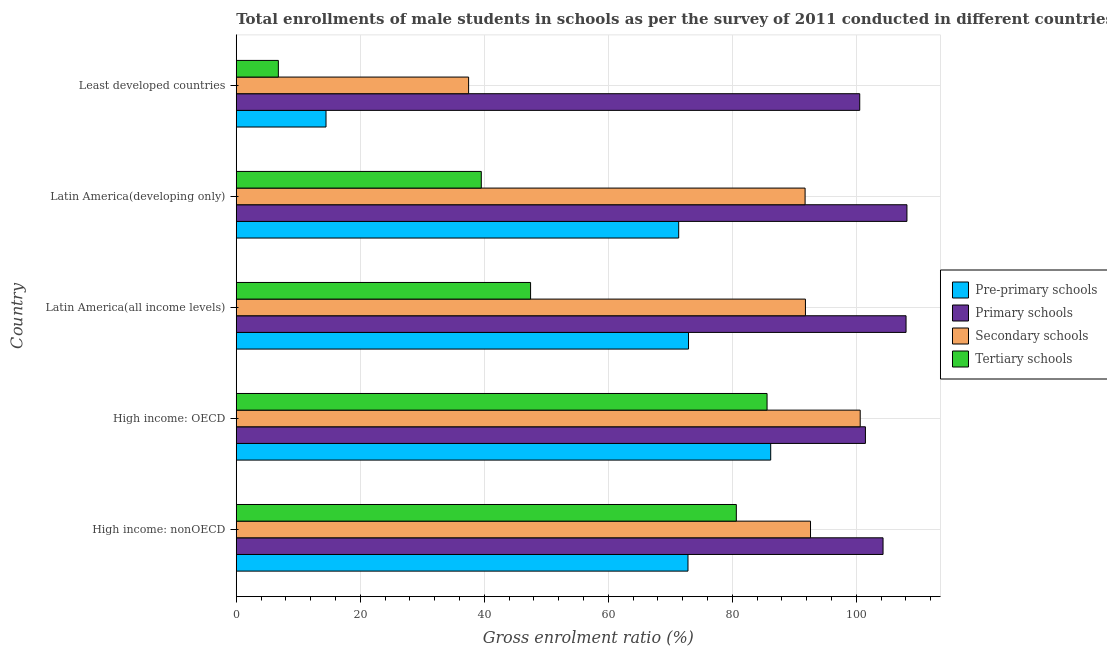What is the label of the 2nd group of bars from the top?
Make the answer very short. Latin America(developing only). What is the gross enrolment ratio(male) in secondary schools in High income: OECD?
Your answer should be compact. 100.64. Across all countries, what is the maximum gross enrolment ratio(male) in secondary schools?
Your answer should be very brief. 100.64. Across all countries, what is the minimum gross enrolment ratio(male) in pre-primary schools?
Your answer should be compact. 14.48. In which country was the gross enrolment ratio(male) in secondary schools maximum?
Make the answer very short. High income: OECD. In which country was the gross enrolment ratio(male) in pre-primary schools minimum?
Provide a succinct answer. Least developed countries. What is the total gross enrolment ratio(male) in primary schools in the graph?
Keep it short and to the point. 522.57. What is the difference between the gross enrolment ratio(male) in secondary schools in High income: OECD and that in Latin America(all income levels)?
Make the answer very short. 8.83. What is the difference between the gross enrolment ratio(male) in secondary schools in High income: OECD and the gross enrolment ratio(male) in primary schools in High income: nonOECD?
Make the answer very short. -3.68. What is the average gross enrolment ratio(male) in secondary schools per country?
Offer a very short reply. 82.86. What is the difference between the gross enrolment ratio(male) in secondary schools and gross enrolment ratio(male) in pre-primary schools in Least developed countries?
Provide a short and direct response. 23. What is the ratio of the gross enrolment ratio(male) in pre-primary schools in High income: nonOECD to that in Least developed countries?
Keep it short and to the point. 5.03. Is the gross enrolment ratio(male) in tertiary schools in High income: nonOECD less than that in Least developed countries?
Your answer should be compact. No. What is the difference between the highest and the second highest gross enrolment ratio(male) in primary schools?
Your answer should be compact. 0.15. What is the difference between the highest and the lowest gross enrolment ratio(male) in secondary schools?
Offer a very short reply. 63.16. Is the sum of the gross enrolment ratio(male) in primary schools in Latin America(developing only) and Least developed countries greater than the maximum gross enrolment ratio(male) in pre-primary schools across all countries?
Your answer should be very brief. Yes. What does the 4th bar from the top in Latin America(developing only) represents?
Provide a short and direct response. Pre-primary schools. What does the 4th bar from the bottom in High income: OECD represents?
Your answer should be compact. Tertiary schools. How many bars are there?
Provide a short and direct response. 20. Does the graph contain any zero values?
Offer a terse response. No. What is the title of the graph?
Keep it short and to the point. Total enrollments of male students in schools as per the survey of 2011 conducted in different countries. What is the label or title of the X-axis?
Provide a short and direct response. Gross enrolment ratio (%). What is the Gross enrolment ratio (%) in Pre-primary schools in High income: nonOECD?
Make the answer very short. 72.86. What is the Gross enrolment ratio (%) in Primary schools in High income: nonOECD?
Give a very brief answer. 104.32. What is the Gross enrolment ratio (%) in Secondary schools in High income: nonOECD?
Ensure brevity in your answer.  92.62. What is the Gross enrolment ratio (%) in Tertiary schools in High income: nonOECD?
Keep it short and to the point. 80.66. What is the Gross enrolment ratio (%) of Pre-primary schools in High income: OECD?
Provide a short and direct response. 86.2. What is the Gross enrolment ratio (%) in Primary schools in High income: OECD?
Your answer should be very brief. 101.48. What is the Gross enrolment ratio (%) in Secondary schools in High income: OECD?
Offer a very short reply. 100.64. What is the Gross enrolment ratio (%) of Tertiary schools in High income: OECD?
Offer a very short reply. 85.61. What is the Gross enrolment ratio (%) in Pre-primary schools in Latin America(all income levels)?
Offer a very short reply. 72.95. What is the Gross enrolment ratio (%) of Primary schools in Latin America(all income levels)?
Make the answer very short. 108.03. What is the Gross enrolment ratio (%) of Secondary schools in Latin America(all income levels)?
Offer a terse response. 91.8. What is the Gross enrolment ratio (%) of Tertiary schools in Latin America(all income levels)?
Offer a very short reply. 47.47. What is the Gross enrolment ratio (%) in Pre-primary schools in Latin America(developing only)?
Offer a terse response. 71.36. What is the Gross enrolment ratio (%) of Primary schools in Latin America(developing only)?
Make the answer very short. 108.18. What is the Gross enrolment ratio (%) in Secondary schools in Latin America(developing only)?
Offer a terse response. 91.75. What is the Gross enrolment ratio (%) of Tertiary schools in Latin America(developing only)?
Your response must be concise. 39.52. What is the Gross enrolment ratio (%) of Pre-primary schools in Least developed countries?
Offer a very short reply. 14.48. What is the Gross enrolment ratio (%) in Primary schools in Least developed countries?
Provide a short and direct response. 100.56. What is the Gross enrolment ratio (%) of Secondary schools in Least developed countries?
Provide a succinct answer. 37.48. What is the Gross enrolment ratio (%) of Tertiary schools in Least developed countries?
Provide a succinct answer. 6.79. Across all countries, what is the maximum Gross enrolment ratio (%) in Pre-primary schools?
Your response must be concise. 86.2. Across all countries, what is the maximum Gross enrolment ratio (%) of Primary schools?
Offer a very short reply. 108.18. Across all countries, what is the maximum Gross enrolment ratio (%) of Secondary schools?
Offer a terse response. 100.64. Across all countries, what is the maximum Gross enrolment ratio (%) in Tertiary schools?
Your answer should be compact. 85.61. Across all countries, what is the minimum Gross enrolment ratio (%) of Pre-primary schools?
Ensure brevity in your answer.  14.48. Across all countries, what is the minimum Gross enrolment ratio (%) of Primary schools?
Provide a succinct answer. 100.56. Across all countries, what is the minimum Gross enrolment ratio (%) of Secondary schools?
Your answer should be compact. 37.48. Across all countries, what is the minimum Gross enrolment ratio (%) of Tertiary schools?
Your answer should be compact. 6.79. What is the total Gross enrolment ratio (%) of Pre-primary schools in the graph?
Provide a short and direct response. 317.84. What is the total Gross enrolment ratio (%) of Primary schools in the graph?
Make the answer very short. 522.57. What is the total Gross enrolment ratio (%) of Secondary schools in the graph?
Provide a short and direct response. 414.29. What is the total Gross enrolment ratio (%) in Tertiary schools in the graph?
Ensure brevity in your answer.  260.06. What is the difference between the Gross enrolment ratio (%) of Pre-primary schools in High income: nonOECD and that in High income: OECD?
Provide a short and direct response. -13.34. What is the difference between the Gross enrolment ratio (%) in Primary schools in High income: nonOECD and that in High income: OECD?
Keep it short and to the point. 2.84. What is the difference between the Gross enrolment ratio (%) in Secondary schools in High income: nonOECD and that in High income: OECD?
Your answer should be very brief. -8.01. What is the difference between the Gross enrolment ratio (%) of Tertiary schools in High income: nonOECD and that in High income: OECD?
Your answer should be compact. -4.96. What is the difference between the Gross enrolment ratio (%) in Pre-primary schools in High income: nonOECD and that in Latin America(all income levels)?
Your response must be concise. -0.09. What is the difference between the Gross enrolment ratio (%) of Primary schools in High income: nonOECD and that in Latin America(all income levels)?
Your answer should be compact. -3.71. What is the difference between the Gross enrolment ratio (%) in Secondary schools in High income: nonOECD and that in Latin America(all income levels)?
Your answer should be very brief. 0.82. What is the difference between the Gross enrolment ratio (%) of Tertiary schools in High income: nonOECD and that in Latin America(all income levels)?
Your response must be concise. 33.18. What is the difference between the Gross enrolment ratio (%) in Pre-primary schools in High income: nonOECD and that in Latin America(developing only)?
Offer a very short reply. 1.5. What is the difference between the Gross enrolment ratio (%) of Primary schools in High income: nonOECD and that in Latin America(developing only)?
Ensure brevity in your answer.  -3.85. What is the difference between the Gross enrolment ratio (%) of Secondary schools in High income: nonOECD and that in Latin America(developing only)?
Give a very brief answer. 0.87. What is the difference between the Gross enrolment ratio (%) of Tertiary schools in High income: nonOECD and that in Latin America(developing only)?
Provide a succinct answer. 41.13. What is the difference between the Gross enrolment ratio (%) in Pre-primary schools in High income: nonOECD and that in Least developed countries?
Provide a succinct answer. 58.38. What is the difference between the Gross enrolment ratio (%) of Primary schools in High income: nonOECD and that in Least developed countries?
Your response must be concise. 3.76. What is the difference between the Gross enrolment ratio (%) of Secondary schools in High income: nonOECD and that in Least developed countries?
Offer a terse response. 55.15. What is the difference between the Gross enrolment ratio (%) of Tertiary schools in High income: nonOECD and that in Least developed countries?
Offer a terse response. 73.87. What is the difference between the Gross enrolment ratio (%) of Pre-primary schools in High income: OECD and that in Latin America(all income levels)?
Offer a terse response. 13.26. What is the difference between the Gross enrolment ratio (%) of Primary schools in High income: OECD and that in Latin America(all income levels)?
Provide a succinct answer. -6.55. What is the difference between the Gross enrolment ratio (%) in Secondary schools in High income: OECD and that in Latin America(all income levels)?
Provide a short and direct response. 8.83. What is the difference between the Gross enrolment ratio (%) of Tertiary schools in High income: OECD and that in Latin America(all income levels)?
Ensure brevity in your answer.  38.14. What is the difference between the Gross enrolment ratio (%) of Pre-primary schools in High income: OECD and that in Latin America(developing only)?
Your answer should be very brief. 14.84. What is the difference between the Gross enrolment ratio (%) in Primary schools in High income: OECD and that in Latin America(developing only)?
Offer a terse response. -6.7. What is the difference between the Gross enrolment ratio (%) in Secondary schools in High income: OECD and that in Latin America(developing only)?
Ensure brevity in your answer.  8.89. What is the difference between the Gross enrolment ratio (%) in Tertiary schools in High income: OECD and that in Latin America(developing only)?
Offer a very short reply. 46.09. What is the difference between the Gross enrolment ratio (%) in Pre-primary schools in High income: OECD and that in Least developed countries?
Offer a terse response. 71.73. What is the difference between the Gross enrolment ratio (%) in Primary schools in High income: OECD and that in Least developed countries?
Give a very brief answer. 0.92. What is the difference between the Gross enrolment ratio (%) of Secondary schools in High income: OECD and that in Least developed countries?
Give a very brief answer. 63.16. What is the difference between the Gross enrolment ratio (%) in Tertiary schools in High income: OECD and that in Least developed countries?
Provide a short and direct response. 78.82. What is the difference between the Gross enrolment ratio (%) in Pre-primary schools in Latin America(all income levels) and that in Latin America(developing only)?
Your answer should be very brief. 1.59. What is the difference between the Gross enrolment ratio (%) of Primary schools in Latin America(all income levels) and that in Latin America(developing only)?
Offer a very short reply. -0.15. What is the difference between the Gross enrolment ratio (%) of Secondary schools in Latin America(all income levels) and that in Latin America(developing only)?
Ensure brevity in your answer.  0.05. What is the difference between the Gross enrolment ratio (%) in Tertiary schools in Latin America(all income levels) and that in Latin America(developing only)?
Provide a short and direct response. 7.95. What is the difference between the Gross enrolment ratio (%) of Pre-primary schools in Latin America(all income levels) and that in Least developed countries?
Make the answer very short. 58.47. What is the difference between the Gross enrolment ratio (%) in Primary schools in Latin America(all income levels) and that in Least developed countries?
Keep it short and to the point. 7.47. What is the difference between the Gross enrolment ratio (%) in Secondary schools in Latin America(all income levels) and that in Least developed countries?
Ensure brevity in your answer.  54.33. What is the difference between the Gross enrolment ratio (%) of Tertiary schools in Latin America(all income levels) and that in Least developed countries?
Offer a very short reply. 40.68. What is the difference between the Gross enrolment ratio (%) of Pre-primary schools in Latin America(developing only) and that in Least developed countries?
Provide a succinct answer. 56.88. What is the difference between the Gross enrolment ratio (%) in Primary schools in Latin America(developing only) and that in Least developed countries?
Ensure brevity in your answer.  7.61. What is the difference between the Gross enrolment ratio (%) of Secondary schools in Latin America(developing only) and that in Least developed countries?
Ensure brevity in your answer.  54.27. What is the difference between the Gross enrolment ratio (%) in Tertiary schools in Latin America(developing only) and that in Least developed countries?
Give a very brief answer. 32.73. What is the difference between the Gross enrolment ratio (%) of Pre-primary schools in High income: nonOECD and the Gross enrolment ratio (%) of Primary schools in High income: OECD?
Give a very brief answer. -28.62. What is the difference between the Gross enrolment ratio (%) of Pre-primary schools in High income: nonOECD and the Gross enrolment ratio (%) of Secondary schools in High income: OECD?
Give a very brief answer. -27.78. What is the difference between the Gross enrolment ratio (%) of Pre-primary schools in High income: nonOECD and the Gross enrolment ratio (%) of Tertiary schools in High income: OECD?
Provide a succinct answer. -12.76. What is the difference between the Gross enrolment ratio (%) of Primary schools in High income: nonOECD and the Gross enrolment ratio (%) of Secondary schools in High income: OECD?
Your answer should be compact. 3.68. What is the difference between the Gross enrolment ratio (%) in Primary schools in High income: nonOECD and the Gross enrolment ratio (%) in Tertiary schools in High income: OECD?
Your answer should be compact. 18.71. What is the difference between the Gross enrolment ratio (%) of Secondary schools in High income: nonOECD and the Gross enrolment ratio (%) of Tertiary schools in High income: OECD?
Keep it short and to the point. 7.01. What is the difference between the Gross enrolment ratio (%) of Pre-primary schools in High income: nonOECD and the Gross enrolment ratio (%) of Primary schools in Latin America(all income levels)?
Offer a terse response. -35.17. What is the difference between the Gross enrolment ratio (%) of Pre-primary schools in High income: nonOECD and the Gross enrolment ratio (%) of Secondary schools in Latin America(all income levels)?
Your response must be concise. -18.94. What is the difference between the Gross enrolment ratio (%) in Pre-primary schools in High income: nonOECD and the Gross enrolment ratio (%) in Tertiary schools in Latin America(all income levels)?
Your answer should be very brief. 25.39. What is the difference between the Gross enrolment ratio (%) of Primary schools in High income: nonOECD and the Gross enrolment ratio (%) of Secondary schools in Latin America(all income levels)?
Your answer should be compact. 12.52. What is the difference between the Gross enrolment ratio (%) in Primary schools in High income: nonOECD and the Gross enrolment ratio (%) in Tertiary schools in Latin America(all income levels)?
Provide a succinct answer. 56.85. What is the difference between the Gross enrolment ratio (%) in Secondary schools in High income: nonOECD and the Gross enrolment ratio (%) in Tertiary schools in Latin America(all income levels)?
Provide a succinct answer. 45.15. What is the difference between the Gross enrolment ratio (%) in Pre-primary schools in High income: nonOECD and the Gross enrolment ratio (%) in Primary schools in Latin America(developing only)?
Offer a very short reply. -35.32. What is the difference between the Gross enrolment ratio (%) in Pre-primary schools in High income: nonOECD and the Gross enrolment ratio (%) in Secondary schools in Latin America(developing only)?
Ensure brevity in your answer.  -18.89. What is the difference between the Gross enrolment ratio (%) of Pre-primary schools in High income: nonOECD and the Gross enrolment ratio (%) of Tertiary schools in Latin America(developing only)?
Offer a terse response. 33.34. What is the difference between the Gross enrolment ratio (%) of Primary schools in High income: nonOECD and the Gross enrolment ratio (%) of Secondary schools in Latin America(developing only)?
Keep it short and to the point. 12.57. What is the difference between the Gross enrolment ratio (%) in Primary schools in High income: nonOECD and the Gross enrolment ratio (%) in Tertiary schools in Latin America(developing only)?
Your answer should be very brief. 64.8. What is the difference between the Gross enrolment ratio (%) in Secondary schools in High income: nonOECD and the Gross enrolment ratio (%) in Tertiary schools in Latin America(developing only)?
Offer a terse response. 53.1. What is the difference between the Gross enrolment ratio (%) of Pre-primary schools in High income: nonOECD and the Gross enrolment ratio (%) of Primary schools in Least developed countries?
Give a very brief answer. -27.7. What is the difference between the Gross enrolment ratio (%) in Pre-primary schools in High income: nonOECD and the Gross enrolment ratio (%) in Secondary schools in Least developed countries?
Make the answer very short. 35.38. What is the difference between the Gross enrolment ratio (%) of Pre-primary schools in High income: nonOECD and the Gross enrolment ratio (%) of Tertiary schools in Least developed countries?
Your answer should be very brief. 66.07. What is the difference between the Gross enrolment ratio (%) of Primary schools in High income: nonOECD and the Gross enrolment ratio (%) of Secondary schools in Least developed countries?
Your answer should be compact. 66.85. What is the difference between the Gross enrolment ratio (%) in Primary schools in High income: nonOECD and the Gross enrolment ratio (%) in Tertiary schools in Least developed countries?
Keep it short and to the point. 97.53. What is the difference between the Gross enrolment ratio (%) of Secondary schools in High income: nonOECD and the Gross enrolment ratio (%) of Tertiary schools in Least developed countries?
Give a very brief answer. 85.83. What is the difference between the Gross enrolment ratio (%) of Pre-primary schools in High income: OECD and the Gross enrolment ratio (%) of Primary schools in Latin America(all income levels)?
Give a very brief answer. -21.83. What is the difference between the Gross enrolment ratio (%) of Pre-primary schools in High income: OECD and the Gross enrolment ratio (%) of Secondary schools in Latin America(all income levels)?
Your answer should be very brief. -5.6. What is the difference between the Gross enrolment ratio (%) of Pre-primary schools in High income: OECD and the Gross enrolment ratio (%) of Tertiary schools in Latin America(all income levels)?
Provide a short and direct response. 38.73. What is the difference between the Gross enrolment ratio (%) in Primary schools in High income: OECD and the Gross enrolment ratio (%) in Secondary schools in Latin America(all income levels)?
Ensure brevity in your answer.  9.68. What is the difference between the Gross enrolment ratio (%) of Primary schools in High income: OECD and the Gross enrolment ratio (%) of Tertiary schools in Latin America(all income levels)?
Your answer should be compact. 54.01. What is the difference between the Gross enrolment ratio (%) of Secondary schools in High income: OECD and the Gross enrolment ratio (%) of Tertiary schools in Latin America(all income levels)?
Your answer should be very brief. 53.16. What is the difference between the Gross enrolment ratio (%) of Pre-primary schools in High income: OECD and the Gross enrolment ratio (%) of Primary schools in Latin America(developing only)?
Ensure brevity in your answer.  -21.97. What is the difference between the Gross enrolment ratio (%) of Pre-primary schools in High income: OECD and the Gross enrolment ratio (%) of Secondary schools in Latin America(developing only)?
Keep it short and to the point. -5.55. What is the difference between the Gross enrolment ratio (%) in Pre-primary schools in High income: OECD and the Gross enrolment ratio (%) in Tertiary schools in Latin America(developing only)?
Provide a succinct answer. 46.68. What is the difference between the Gross enrolment ratio (%) in Primary schools in High income: OECD and the Gross enrolment ratio (%) in Secondary schools in Latin America(developing only)?
Keep it short and to the point. 9.73. What is the difference between the Gross enrolment ratio (%) of Primary schools in High income: OECD and the Gross enrolment ratio (%) of Tertiary schools in Latin America(developing only)?
Keep it short and to the point. 61.96. What is the difference between the Gross enrolment ratio (%) of Secondary schools in High income: OECD and the Gross enrolment ratio (%) of Tertiary schools in Latin America(developing only)?
Make the answer very short. 61.11. What is the difference between the Gross enrolment ratio (%) of Pre-primary schools in High income: OECD and the Gross enrolment ratio (%) of Primary schools in Least developed countries?
Make the answer very short. -14.36. What is the difference between the Gross enrolment ratio (%) of Pre-primary schools in High income: OECD and the Gross enrolment ratio (%) of Secondary schools in Least developed countries?
Provide a short and direct response. 48.73. What is the difference between the Gross enrolment ratio (%) of Pre-primary schools in High income: OECD and the Gross enrolment ratio (%) of Tertiary schools in Least developed countries?
Make the answer very short. 79.41. What is the difference between the Gross enrolment ratio (%) of Primary schools in High income: OECD and the Gross enrolment ratio (%) of Secondary schools in Least developed countries?
Ensure brevity in your answer.  64. What is the difference between the Gross enrolment ratio (%) of Primary schools in High income: OECD and the Gross enrolment ratio (%) of Tertiary schools in Least developed countries?
Your answer should be very brief. 94.69. What is the difference between the Gross enrolment ratio (%) of Secondary schools in High income: OECD and the Gross enrolment ratio (%) of Tertiary schools in Least developed countries?
Your answer should be compact. 93.85. What is the difference between the Gross enrolment ratio (%) of Pre-primary schools in Latin America(all income levels) and the Gross enrolment ratio (%) of Primary schools in Latin America(developing only)?
Your answer should be very brief. -35.23. What is the difference between the Gross enrolment ratio (%) of Pre-primary schools in Latin America(all income levels) and the Gross enrolment ratio (%) of Secondary schools in Latin America(developing only)?
Make the answer very short. -18.8. What is the difference between the Gross enrolment ratio (%) in Pre-primary schools in Latin America(all income levels) and the Gross enrolment ratio (%) in Tertiary schools in Latin America(developing only)?
Your answer should be very brief. 33.42. What is the difference between the Gross enrolment ratio (%) in Primary schools in Latin America(all income levels) and the Gross enrolment ratio (%) in Secondary schools in Latin America(developing only)?
Ensure brevity in your answer.  16.28. What is the difference between the Gross enrolment ratio (%) in Primary schools in Latin America(all income levels) and the Gross enrolment ratio (%) in Tertiary schools in Latin America(developing only)?
Provide a succinct answer. 68.51. What is the difference between the Gross enrolment ratio (%) in Secondary schools in Latin America(all income levels) and the Gross enrolment ratio (%) in Tertiary schools in Latin America(developing only)?
Make the answer very short. 52.28. What is the difference between the Gross enrolment ratio (%) in Pre-primary schools in Latin America(all income levels) and the Gross enrolment ratio (%) in Primary schools in Least developed countries?
Make the answer very short. -27.62. What is the difference between the Gross enrolment ratio (%) of Pre-primary schools in Latin America(all income levels) and the Gross enrolment ratio (%) of Secondary schools in Least developed countries?
Your answer should be very brief. 35.47. What is the difference between the Gross enrolment ratio (%) of Pre-primary schools in Latin America(all income levels) and the Gross enrolment ratio (%) of Tertiary schools in Least developed countries?
Your answer should be very brief. 66.16. What is the difference between the Gross enrolment ratio (%) of Primary schools in Latin America(all income levels) and the Gross enrolment ratio (%) of Secondary schools in Least developed countries?
Give a very brief answer. 70.55. What is the difference between the Gross enrolment ratio (%) in Primary schools in Latin America(all income levels) and the Gross enrolment ratio (%) in Tertiary schools in Least developed countries?
Your response must be concise. 101.24. What is the difference between the Gross enrolment ratio (%) in Secondary schools in Latin America(all income levels) and the Gross enrolment ratio (%) in Tertiary schools in Least developed countries?
Your answer should be very brief. 85.01. What is the difference between the Gross enrolment ratio (%) of Pre-primary schools in Latin America(developing only) and the Gross enrolment ratio (%) of Primary schools in Least developed countries?
Provide a short and direct response. -29.2. What is the difference between the Gross enrolment ratio (%) in Pre-primary schools in Latin America(developing only) and the Gross enrolment ratio (%) in Secondary schools in Least developed countries?
Provide a short and direct response. 33.88. What is the difference between the Gross enrolment ratio (%) in Pre-primary schools in Latin America(developing only) and the Gross enrolment ratio (%) in Tertiary schools in Least developed countries?
Provide a succinct answer. 64.57. What is the difference between the Gross enrolment ratio (%) in Primary schools in Latin America(developing only) and the Gross enrolment ratio (%) in Secondary schools in Least developed countries?
Give a very brief answer. 70.7. What is the difference between the Gross enrolment ratio (%) in Primary schools in Latin America(developing only) and the Gross enrolment ratio (%) in Tertiary schools in Least developed countries?
Provide a short and direct response. 101.39. What is the difference between the Gross enrolment ratio (%) in Secondary schools in Latin America(developing only) and the Gross enrolment ratio (%) in Tertiary schools in Least developed countries?
Ensure brevity in your answer.  84.96. What is the average Gross enrolment ratio (%) of Pre-primary schools per country?
Your answer should be compact. 63.57. What is the average Gross enrolment ratio (%) in Primary schools per country?
Make the answer very short. 104.51. What is the average Gross enrolment ratio (%) of Secondary schools per country?
Give a very brief answer. 82.86. What is the average Gross enrolment ratio (%) of Tertiary schools per country?
Keep it short and to the point. 52.01. What is the difference between the Gross enrolment ratio (%) of Pre-primary schools and Gross enrolment ratio (%) of Primary schools in High income: nonOECD?
Provide a short and direct response. -31.46. What is the difference between the Gross enrolment ratio (%) in Pre-primary schools and Gross enrolment ratio (%) in Secondary schools in High income: nonOECD?
Your answer should be compact. -19.76. What is the difference between the Gross enrolment ratio (%) in Pre-primary schools and Gross enrolment ratio (%) in Tertiary schools in High income: nonOECD?
Your response must be concise. -7.8. What is the difference between the Gross enrolment ratio (%) in Primary schools and Gross enrolment ratio (%) in Secondary schools in High income: nonOECD?
Keep it short and to the point. 11.7. What is the difference between the Gross enrolment ratio (%) of Primary schools and Gross enrolment ratio (%) of Tertiary schools in High income: nonOECD?
Keep it short and to the point. 23.66. What is the difference between the Gross enrolment ratio (%) of Secondary schools and Gross enrolment ratio (%) of Tertiary schools in High income: nonOECD?
Make the answer very short. 11.97. What is the difference between the Gross enrolment ratio (%) of Pre-primary schools and Gross enrolment ratio (%) of Primary schools in High income: OECD?
Offer a terse response. -15.28. What is the difference between the Gross enrolment ratio (%) of Pre-primary schools and Gross enrolment ratio (%) of Secondary schools in High income: OECD?
Give a very brief answer. -14.43. What is the difference between the Gross enrolment ratio (%) of Pre-primary schools and Gross enrolment ratio (%) of Tertiary schools in High income: OECD?
Ensure brevity in your answer.  0.59. What is the difference between the Gross enrolment ratio (%) of Primary schools and Gross enrolment ratio (%) of Secondary schools in High income: OECD?
Ensure brevity in your answer.  0.84. What is the difference between the Gross enrolment ratio (%) of Primary schools and Gross enrolment ratio (%) of Tertiary schools in High income: OECD?
Offer a very short reply. 15.86. What is the difference between the Gross enrolment ratio (%) of Secondary schools and Gross enrolment ratio (%) of Tertiary schools in High income: OECD?
Give a very brief answer. 15.02. What is the difference between the Gross enrolment ratio (%) of Pre-primary schools and Gross enrolment ratio (%) of Primary schools in Latin America(all income levels)?
Your answer should be compact. -35.08. What is the difference between the Gross enrolment ratio (%) in Pre-primary schools and Gross enrolment ratio (%) in Secondary schools in Latin America(all income levels)?
Give a very brief answer. -18.86. What is the difference between the Gross enrolment ratio (%) of Pre-primary schools and Gross enrolment ratio (%) of Tertiary schools in Latin America(all income levels)?
Offer a terse response. 25.47. What is the difference between the Gross enrolment ratio (%) in Primary schools and Gross enrolment ratio (%) in Secondary schools in Latin America(all income levels)?
Your response must be concise. 16.23. What is the difference between the Gross enrolment ratio (%) of Primary schools and Gross enrolment ratio (%) of Tertiary schools in Latin America(all income levels)?
Your answer should be compact. 60.56. What is the difference between the Gross enrolment ratio (%) in Secondary schools and Gross enrolment ratio (%) in Tertiary schools in Latin America(all income levels)?
Make the answer very short. 44.33. What is the difference between the Gross enrolment ratio (%) of Pre-primary schools and Gross enrolment ratio (%) of Primary schools in Latin America(developing only)?
Make the answer very short. -36.82. What is the difference between the Gross enrolment ratio (%) of Pre-primary schools and Gross enrolment ratio (%) of Secondary schools in Latin America(developing only)?
Keep it short and to the point. -20.39. What is the difference between the Gross enrolment ratio (%) of Pre-primary schools and Gross enrolment ratio (%) of Tertiary schools in Latin America(developing only)?
Your answer should be very brief. 31.84. What is the difference between the Gross enrolment ratio (%) in Primary schools and Gross enrolment ratio (%) in Secondary schools in Latin America(developing only)?
Your response must be concise. 16.43. What is the difference between the Gross enrolment ratio (%) of Primary schools and Gross enrolment ratio (%) of Tertiary schools in Latin America(developing only)?
Your response must be concise. 68.65. What is the difference between the Gross enrolment ratio (%) of Secondary schools and Gross enrolment ratio (%) of Tertiary schools in Latin America(developing only)?
Offer a terse response. 52.23. What is the difference between the Gross enrolment ratio (%) of Pre-primary schools and Gross enrolment ratio (%) of Primary schools in Least developed countries?
Provide a short and direct response. -86.09. What is the difference between the Gross enrolment ratio (%) in Pre-primary schools and Gross enrolment ratio (%) in Secondary schools in Least developed countries?
Ensure brevity in your answer.  -23. What is the difference between the Gross enrolment ratio (%) of Pre-primary schools and Gross enrolment ratio (%) of Tertiary schools in Least developed countries?
Your response must be concise. 7.69. What is the difference between the Gross enrolment ratio (%) of Primary schools and Gross enrolment ratio (%) of Secondary schools in Least developed countries?
Provide a short and direct response. 63.09. What is the difference between the Gross enrolment ratio (%) of Primary schools and Gross enrolment ratio (%) of Tertiary schools in Least developed countries?
Provide a succinct answer. 93.77. What is the difference between the Gross enrolment ratio (%) in Secondary schools and Gross enrolment ratio (%) in Tertiary schools in Least developed countries?
Provide a succinct answer. 30.69. What is the ratio of the Gross enrolment ratio (%) in Pre-primary schools in High income: nonOECD to that in High income: OECD?
Ensure brevity in your answer.  0.85. What is the ratio of the Gross enrolment ratio (%) of Primary schools in High income: nonOECD to that in High income: OECD?
Your answer should be compact. 1.03. What is the ratio of the Gross enrolment ratio (%) in Secondary schools in High income: nonOECD to that in High income: OECD?
Offer a very short reply. 0.92. What is the ratio of the Gross enrolment ratio (%) in Tertiary schools in High income: nonOECD to that in High income: OECD?
Your answer should be very brief. 0.94. What is the ratio of the Gross enrolment ratio (%) of Pre-primary schools in High income: nonOECD to that in Latin America(all income levels)?
Keep it short and to the point. 1. What is the ratio of the Gross enrolment ratio (%) in Primary schools in High income: nonOECD to that in Latin America(all income levels)?
Your response must be concise. 0.97. What is the ratio of the Gross enrolment ratio (%) of Secondary schools in High income: nonOECD to that in Latin America(all income levels)?
Give a very brief answer. 1.01. What is the ratio of the Gross enrolment ratio (%) of Tertiary schools in High income: nonOECD to that in Latin America(all income levels)?
Ensure brevity in your answer.  1.7. What is the ratio of the Gross enrolment ratio (%) of Primary schools in High income: nonOECD to that in Latin America(developing only)?
Keep it short and to the point. 0.96. What is the ratio of the Gross enrolment ratio (%) in Secondary schools in High income: nonOECD to that in Latin America(developing only)?
Your answer should be compact. 1.01. What is the ratio of the Gross enrolment ratio (%) of Tertiary schools in High income: nonOECD to that in Latin America(developing only)?
Keep it short and to the point. 2.04. What is the ratio of the Gross enrolment ratio (%) in Pre-primary schools in High income: nonOECD to that in Least developed countries?
Keep it short and to the point. 5.03. What is the ratio of the Gross enrolment ratio (%) in Primary schools in High income: nonOECD to that in Least developed countries?
Your answer should be compact. 1.04. What is the ratio of the Gross enrolment ratio (%) in Secondary schools in High income: nonOECD to that in Least developed countries?
Offer a very short reply. 2.47. What is the ratio of the Gross enrolment ratio (%) in Tertiary schools in High income: nonOECD to that in Least developed countries?
Make the answer very short. 11.88. What is the ratio of the Gross enrolment ratio (%) of Pre-primary schools in High income: OECD to that in Latin America(all income levels)?
Ensure brevity in your answer.  1.18. What is the ratio of the Gross enrolment ratio (%) in Primary schools in High income: OECD to that in Latin America(all income levels)?
Your answer should be compact. 0.94. What is the ratio of the Gross enrolment ratio (%) of Secondary schools in High income: OECD to that in Latin America(all income levels)?
Make the answer very short. 1.1. What is the ratio of the Gross enrolment ratio (%) in Tertiary schools in High income: OECD to that in Latin America(all income levels)?
Your answer should be compact. 1.8. What is the ratio of the Gross enrolment ratio (%) in Pre-primary schools in High income: OECD to that in Latin America(developing only)?
Give a very brief answer. 1.21. What is the ratio of the Gross enrolment ratio (%) in Primary schools in High income: OECD to that in Latin America(developing only)?
Offer a terse response. 0.94. What is the ratio of the Gross enrolment ratio (%) in Secondary schools in High income: OECD to that in Latin America(developing only)?
Offer a terse response. 1.1. What is the ratio of the Gross enrolment ratio (%) of Tertiary schools in High income: OECD to that in Latin America(developing only)?
Give a very brief answer. 2.17. What is the ratio of the Gross enrolment ratio (%) in Pre-primary schools in High income: OECD to that in Least developed countries?
Your answer should be very brief. 5.95. What is the ratio of the Gross enrolment ratio (%) of Primary schools in High income: OECD to that in Least developed countries?
Offer a terse response. 1.01. What is the ratio of the Gross enrolment ratio (%) of Secondary schools in High income: OECD to that in Least developed countries?
Offer a terse response. 2.69. What is the ratio of the Gross enrolment ratio (%) of Tertiary schools in High income: OECD to that in Least developed countries?
Offer a terse response. 12.61. What is the ratio of the Gross enrolment ratio (%) in Pre-primary schools in Latin America(all income levels) to that in Latin America(developing only)?
Make the answer very short. 1.02. What is the ratio of the Gross enrolment ratio (%) of Primary schools in Latin America(all income levels) to that in Latin America(developing only)?
Your answer should be very brief. 1. What is the ratio of the Gross enrolment ratio (%) of Tertiary schools in Latin America(all income levels) to that in Latin America(developing only)?
Make the answer very short. 1.2. What is the ratio of the Gross enrolment ratio (%) in Pre-primary schools in Latin America(all income levels) to that in Least developed countries?
Keep it short and to the point. 5.04. What is the ratio of the Gross enrolment ratio (%) in Primary schools in Latin America(all income levels) to that in Least developed countries?
Your answer should be compact. 1.07. What is the ratio of the Gross enrolment ratio (%) of Secondary schools in Latin America(all income levels) to that in Least developed countries?
Keep it short and to the point. 2.45. What is the ratio of the Gross enrolment ratio (%) in Tertiary schools in Latin America(all income levels) to that in Least developed countries?
Provide a succinct answer. 6.99. What is the ratio of the Gross enrolment ratio (%) in Pre-primary schools in Latin America(developing only) to that in Least developed countries?
Provide a short and direct response. 4.93. What is the ratio of the Gross enrolment ratio (%) in Primary schools in Latin America(developing only) to that in Least developed countries?
Keep it short and to the point. 1.08. What is the ratio of the Gross enrolment ratio (%) in Secondary schools in Latin America(developing only) to that in Least developed countries?
Provide a short and direct response. 2.45. What is the ratio of the Gross enrolment ratio (%) of Tertiary schools in Latin America(developing only) to that in Least developed countries?
Provide a short and direct response. 5.82. What is the difference between the highest and the second highest Gross enrolment ratio (%) in Pre-primary schools?
Make the answer very short. 13.26. What is the difference between the highest and the second highest Gross enrolment ratio (%) of Primary schools?
Make the answer very short. 0.15. What is the difference between the highest and the second highest Gross enrolment ratio (%) of Secondary schools?
Ensure brevity in your answer.  8.01. What is the difference between the highest and the second highest Gross enrolment ratio (%) of Tertiary schools?
Your answer should be very brief. 4.96. What is the difference between the highest and the lowest Gross enrolment ratio (%) of Pre-primary schools?
Your answer should be compact. 71.73. What is the difference between the highest and the lowest Gross enrolment ratio (%) in Primary schools?
Your answer should be very brief. 7.61. What is the difference between the highest and the lowest Gross enrolment ratio (%) in Secondary schools?
Provide a short and direct response. 63.16. What is the difference between the highest and the lowest Gross enrolment ratio (%) of Tertiary schools?
Make the answer very short. 78.82. 